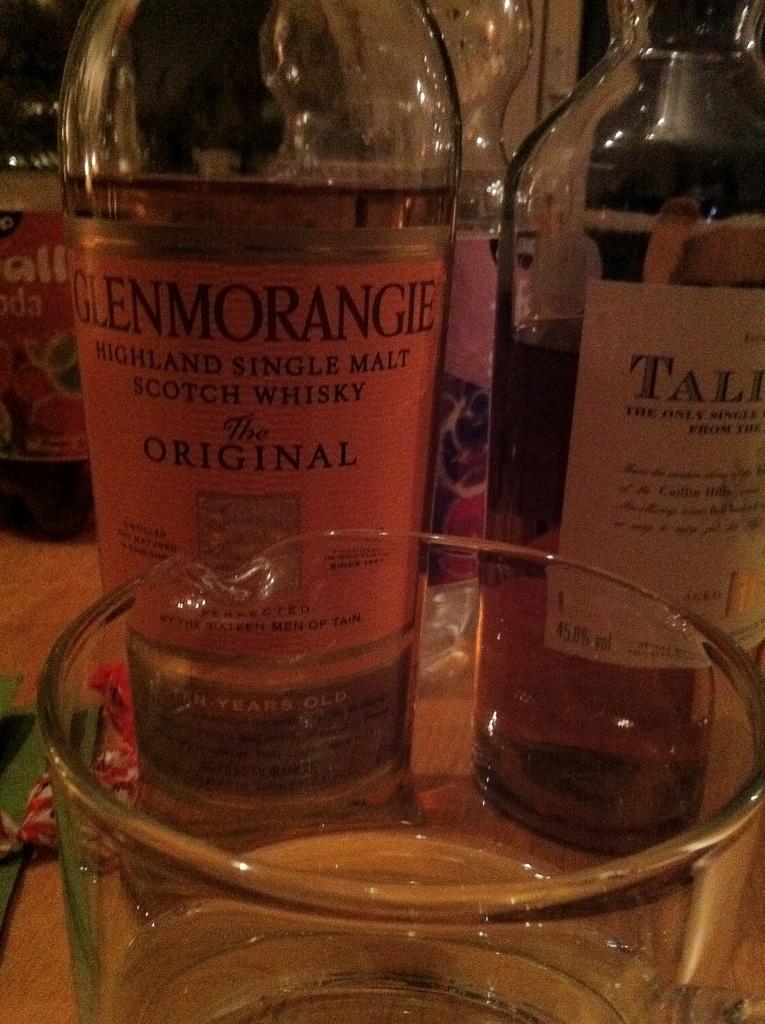What kind of whiskey is this?
Provide a short and direct response. Glenmorangie. What type of malt is this?
Offer a terse response. Single malt. 